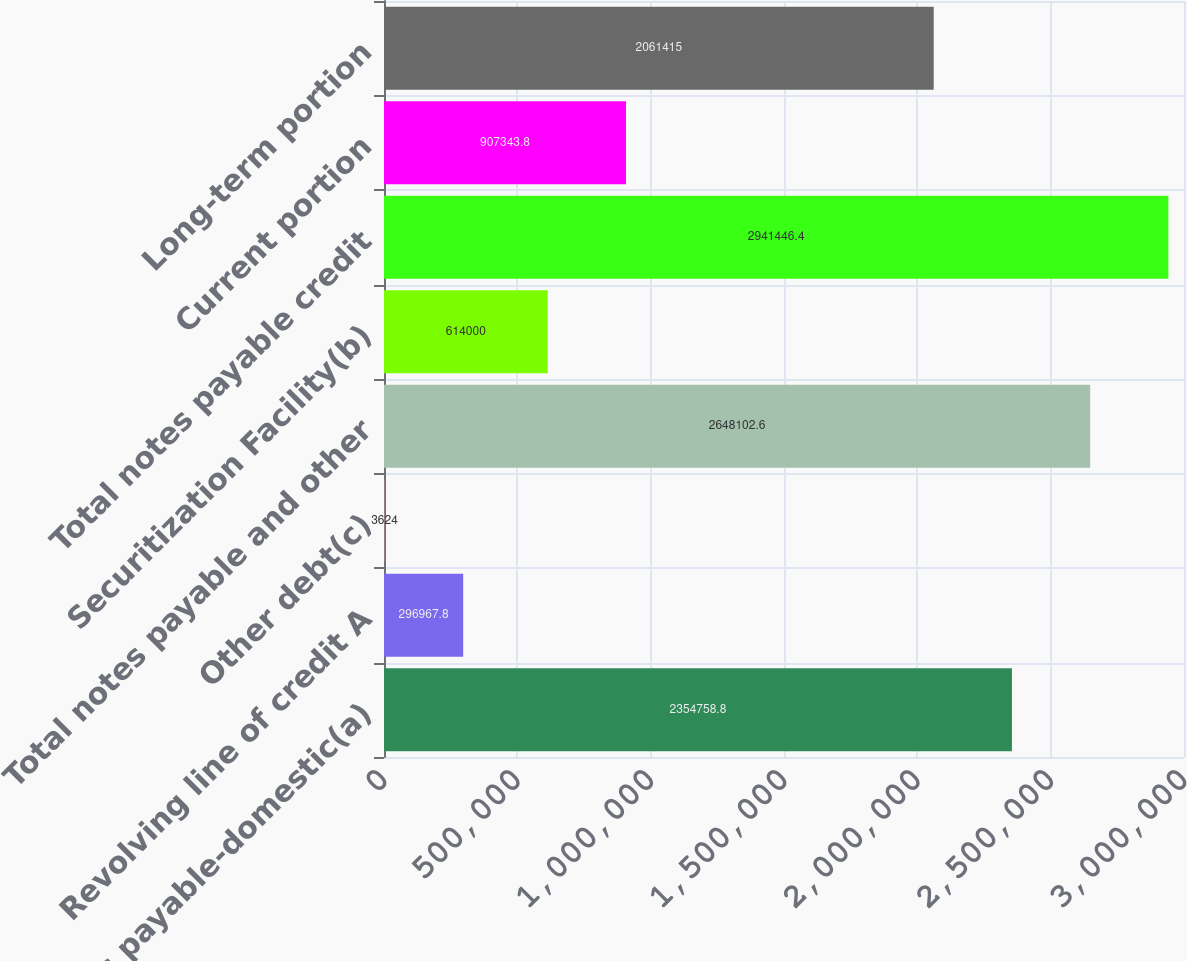Convert chart. <chart><loc_0><loc_0><loc_500><loc_500><bar_chart><fcel>Term notes payable-domestic(a)<fcel>Revolving line of credit A<fcel>Other debt(c)<fcel>Total notes payable and other<fcel>Securitization Facility(b)<fcel>Total notes payable credit<fcel>Current portion<fcel>Long-term portion<nl><fcel>2.35476e+06<fcel>296968<fcel>3624<fcel>2.6481e+06<fcel>614000<fcel>2.94145e+06<fcel>907344<fcel>2.06142e+06<nl></chart> 